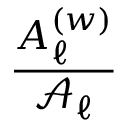<formula> <loc_0><loc_0><loc_500><loc_500>\frac { A _ { \ell } ^ { ( w ) } } { \mathcal { A } _ { \ell } }</formula> 